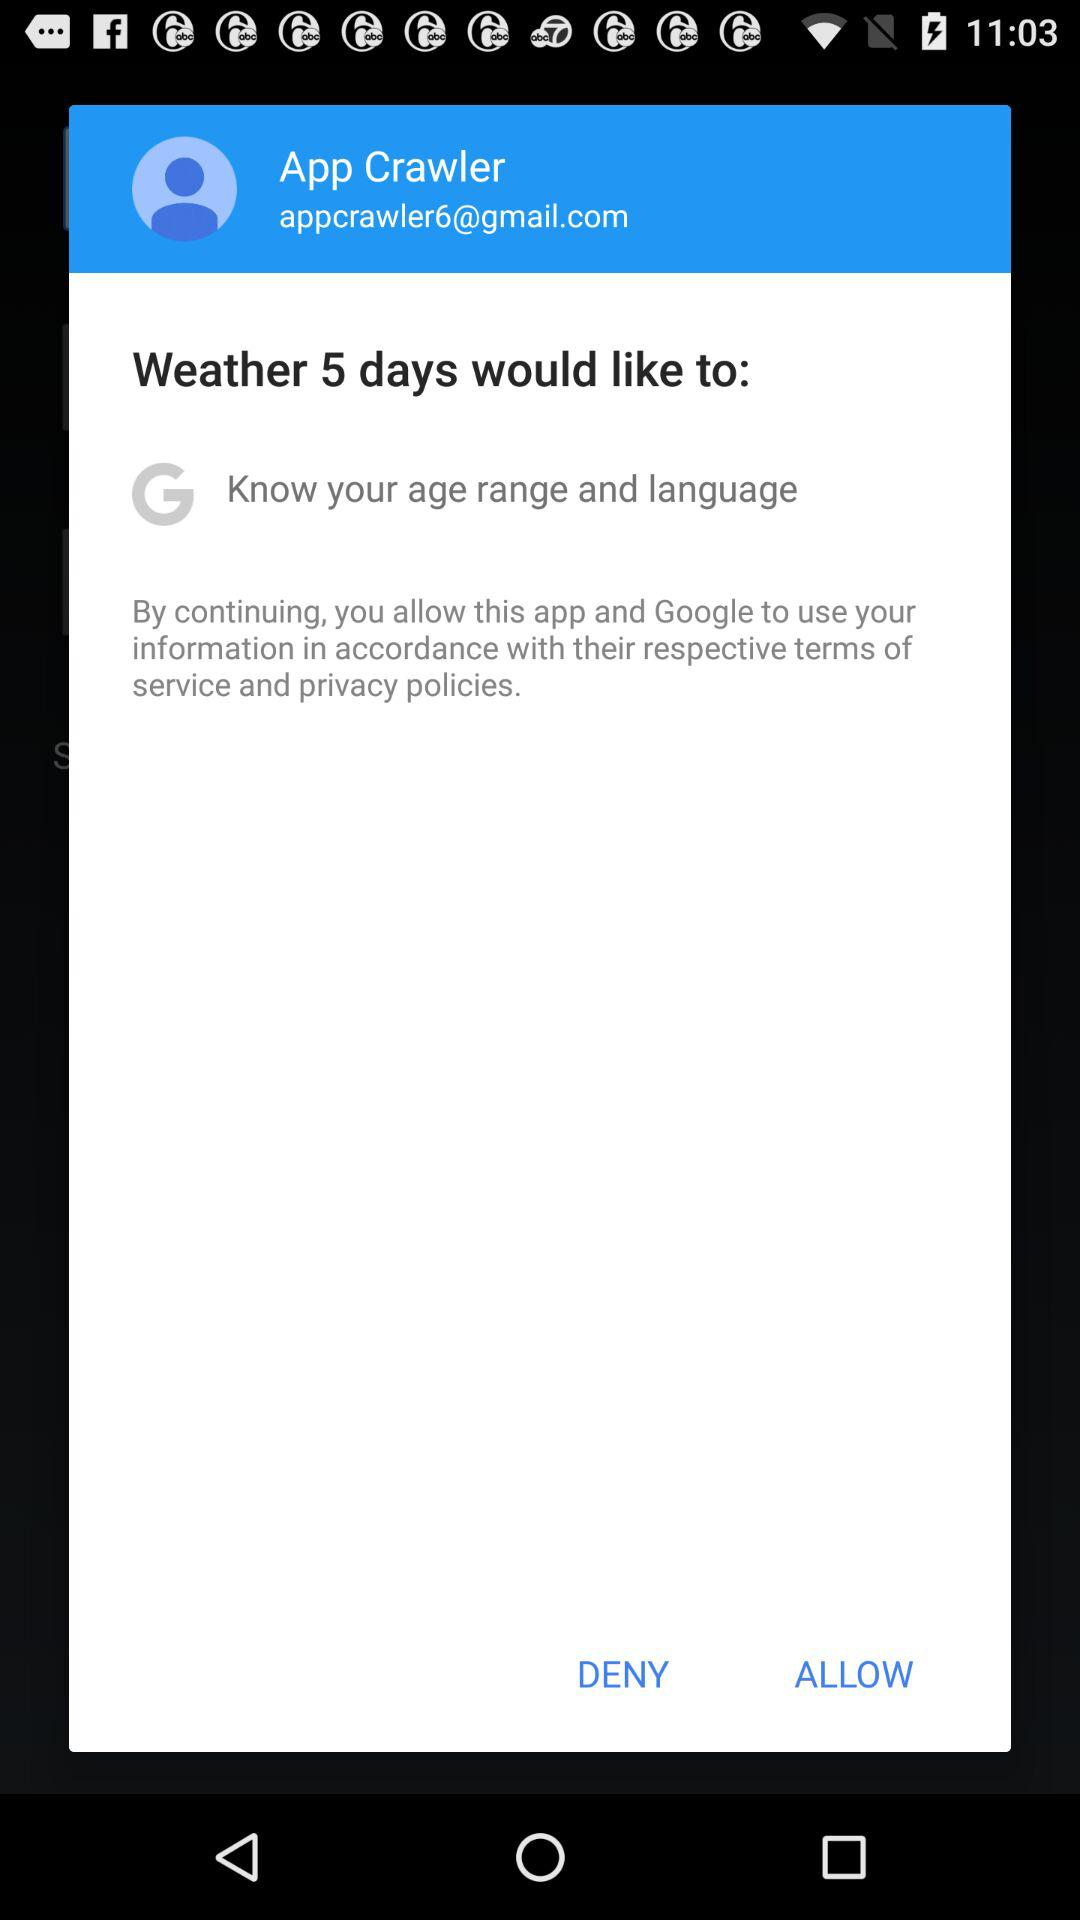What is the email address? The email address is appcrawler6@gmail.com. 